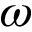<formula> <loc_0><loc_0><loc_500><loc_500>\omega</formula> 